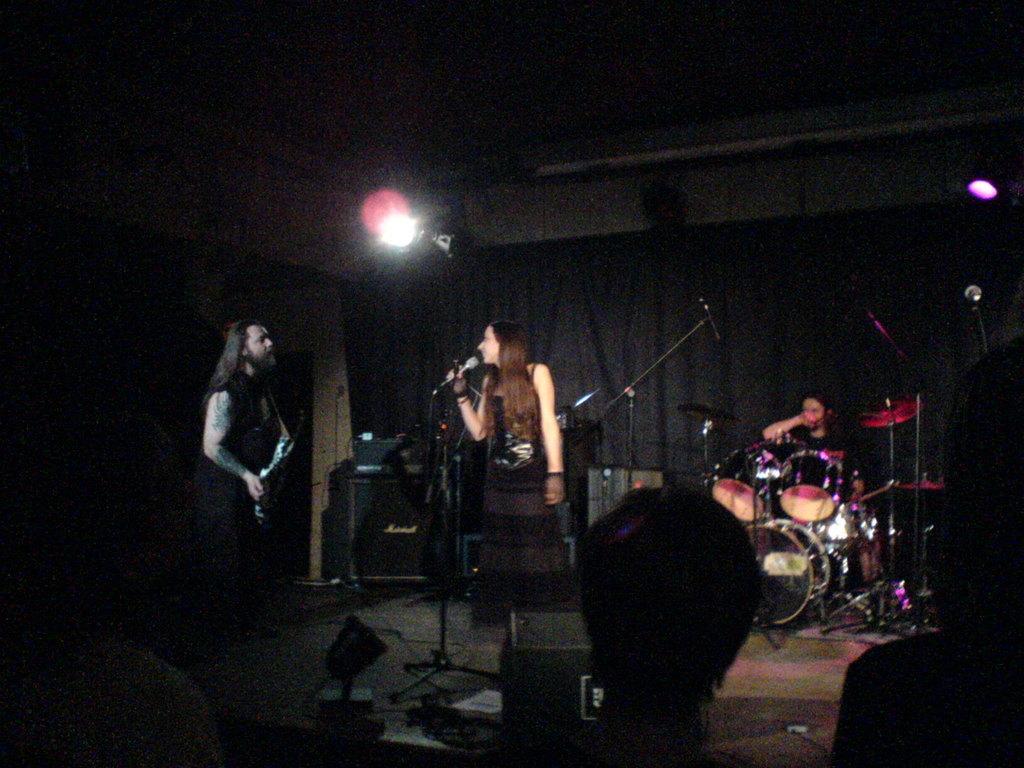Can you describe this image briefly? Here in this picture on the right side we can see a person playing drums and in the middle we can see a lady saying song with a Microphone in front of her and on the left side we can see a person playing guitar and there are other musical instruments present on the stage and there are lights present and in front of them we can see people plant 